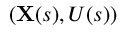Convert formula to latex. <formula><loc_0><loc_0><loc_500><loc_500>( X ( s ) , U ( s ) )</formula> 